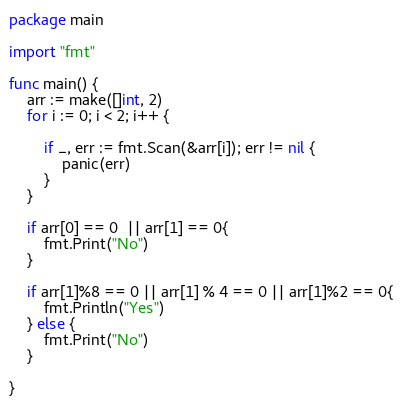Convert code to text. <code><loc_0><loc_0><loc_500><loc_500><_Go_>package main

import "fmt"

func main() {
	arr := make([]int, 2)
	for i := 0; i < 2; i++ {

		if _, err := fmt.Scan(&arr[i]); err != nil {
			panic(err)
		}
	}

	if arr[0] == 0  || arr[1] == 0{
		fmt.Print("No")
	}

	if arr[1]%8 == 0 || arr[1] % 4 == 0 || arr[1]%2 == 0{
		fmt.Println("Yes")
	} else {
		fmt.Print("No")
	}

}
</code> 